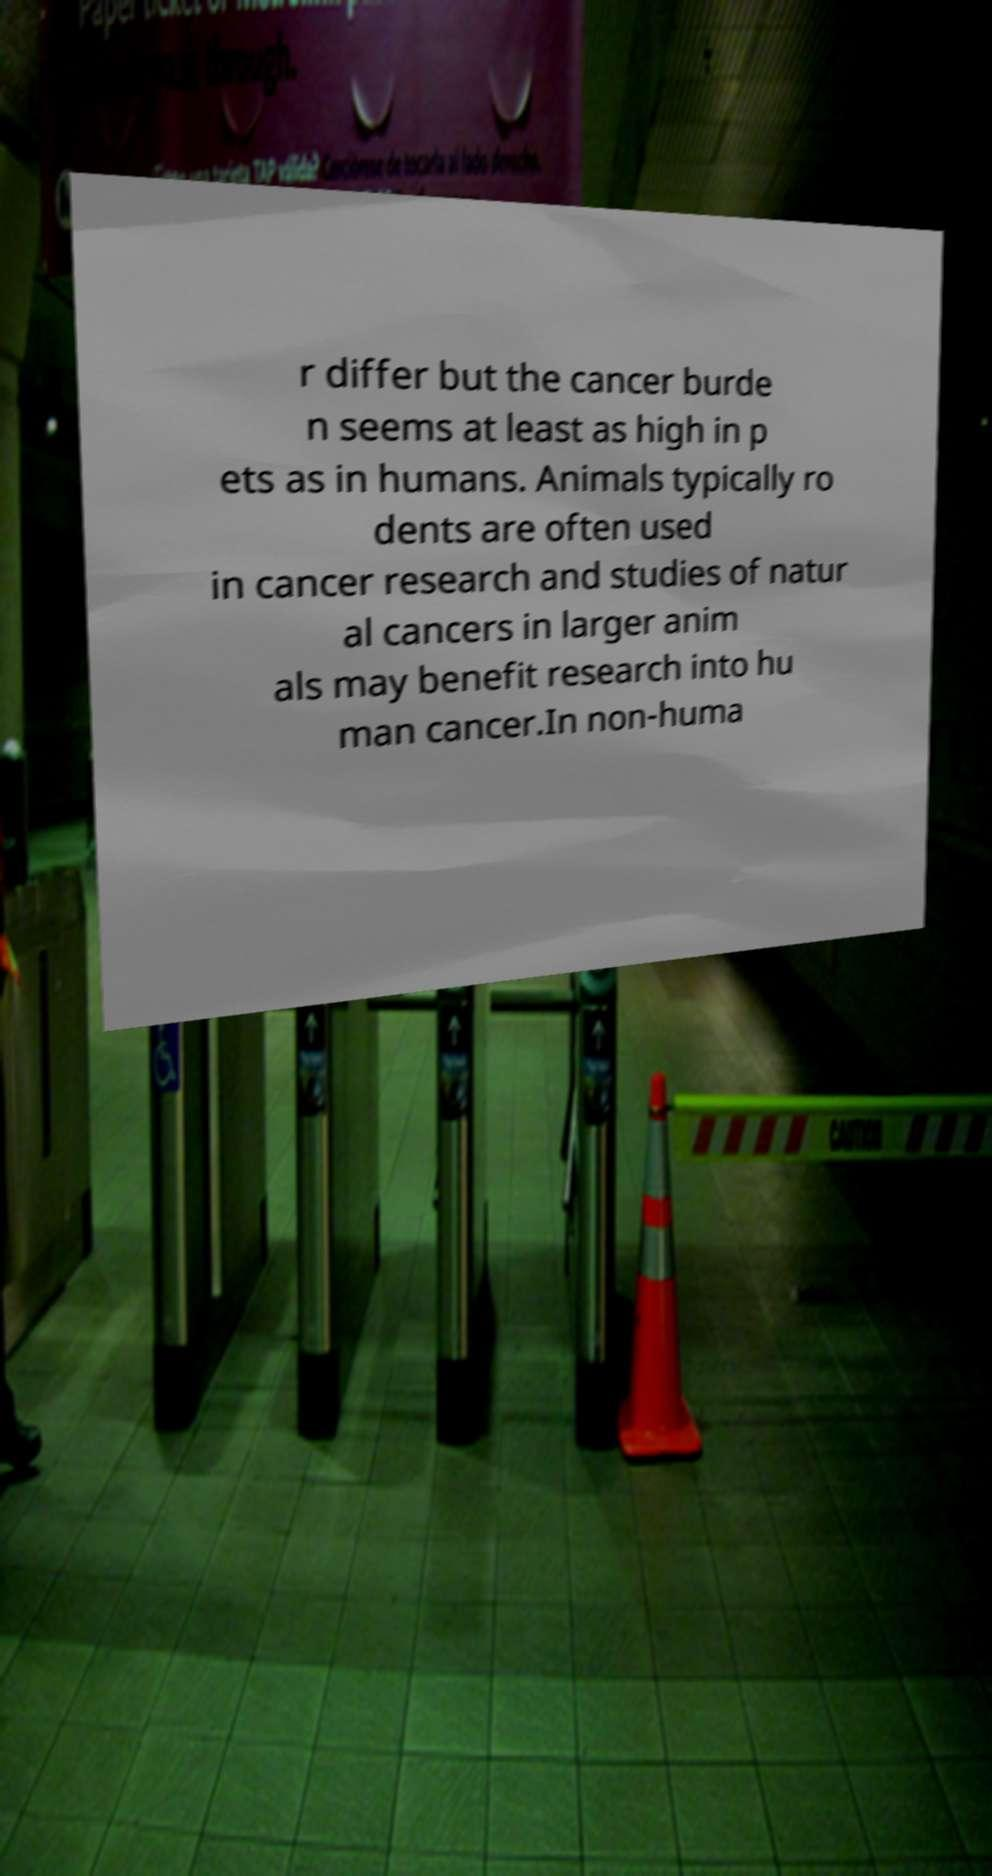Could you extract and type out the text from this image? r differ but the cancer burde n seems at least as high in p ets as in humans. Animals typically ro dents are often used in cancer research and studies of natur al cancers in larger anim als may benefit research into hu man cancer.In non-huma 